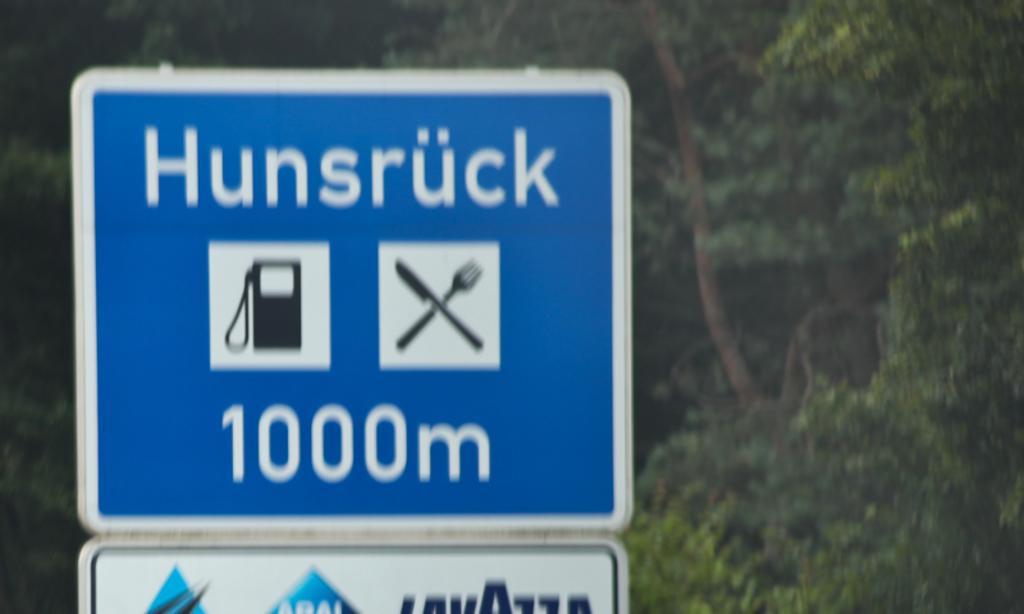How would you summarize this image in a sentence or two? In the center of the image there is a sign board. In the background of the image there are trees. 